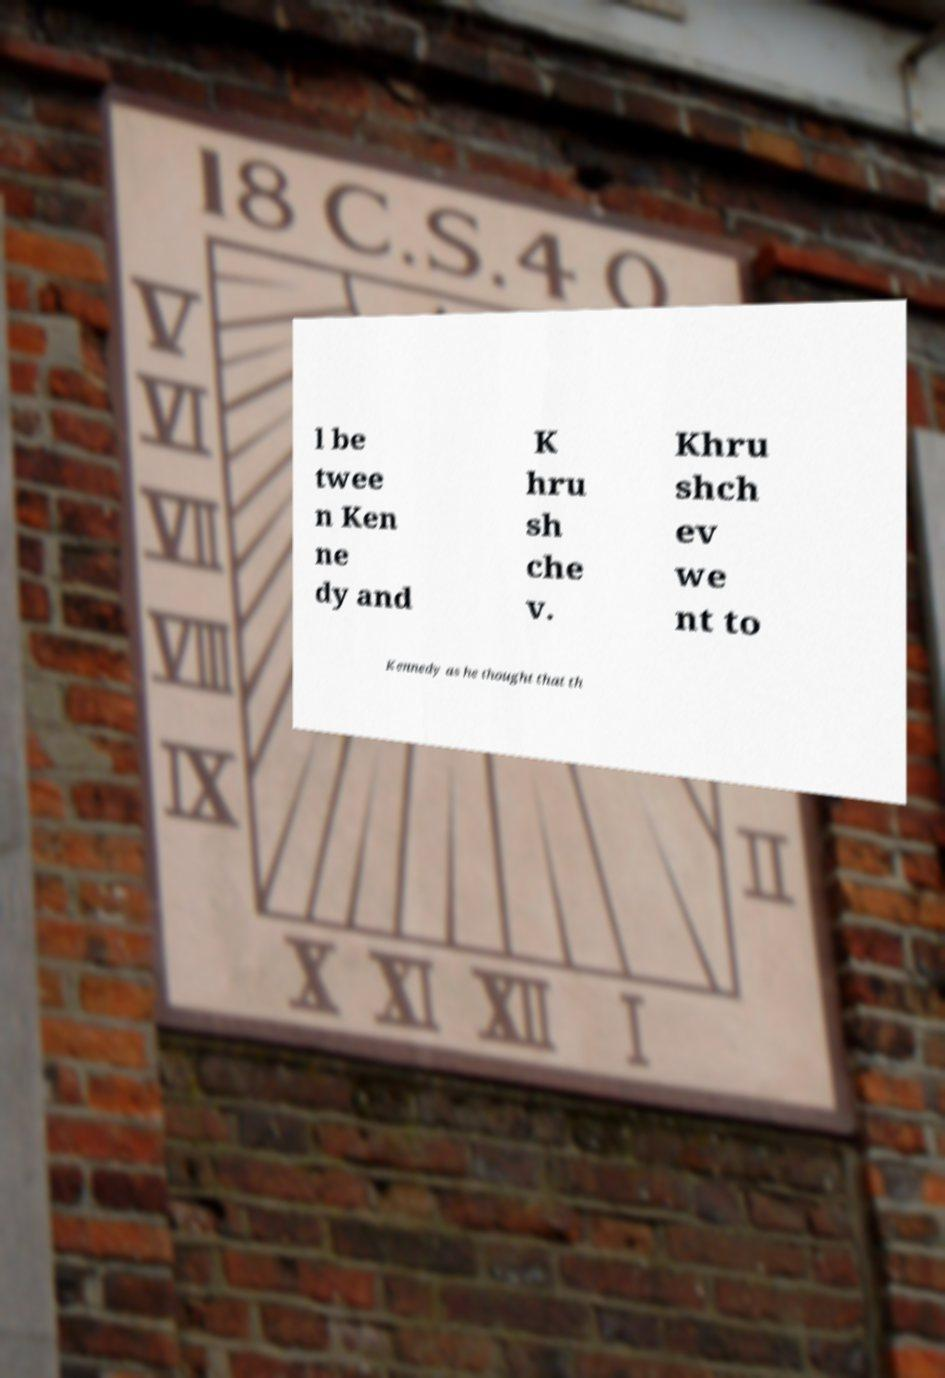Could you extract and type out the text from this image? l be twee n Ken ne dy and K hru sh che v. Khru shch ev we nt to Kennedy as he thought that th 